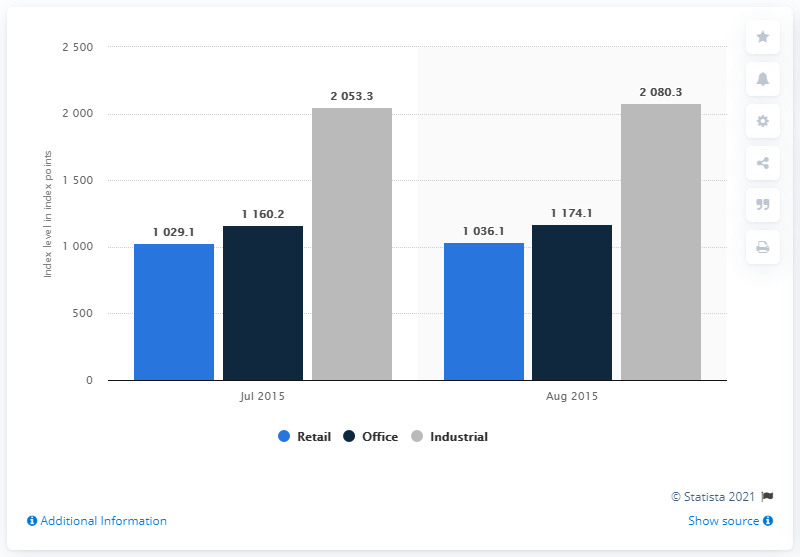Indicate a few pertinent items in this graphic. In July and August 2015, the index point for industrial property was 2080.3. 